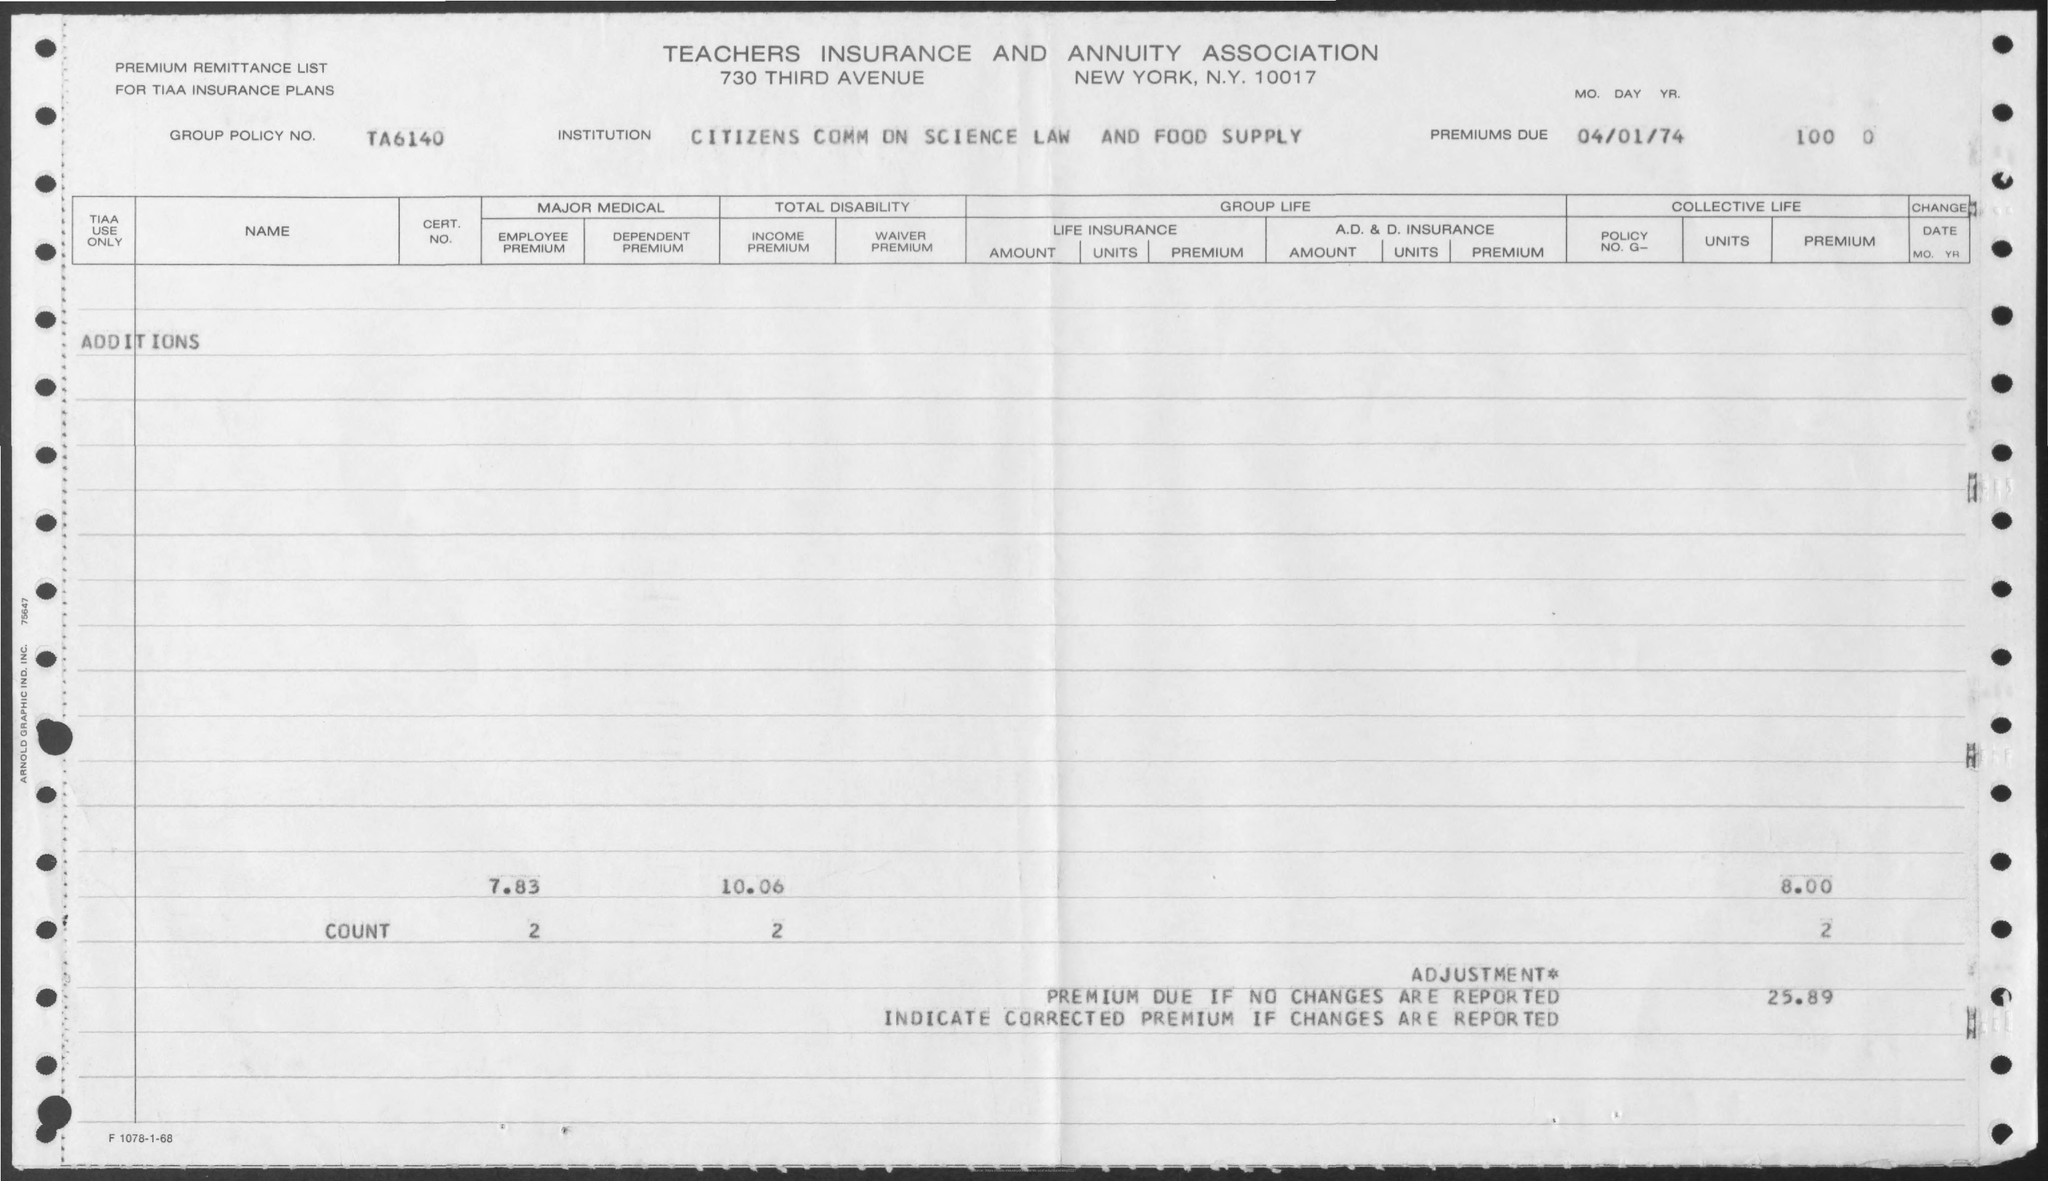What is the Group Policy Number?
Provide a succinct answer. TA6140. What is the name of the Institution?
Your response must be concise. Citizens comm on science law and food supply. What is the title of the document?
Your answer should be compact. Teachers Insurance and Annuity association. 